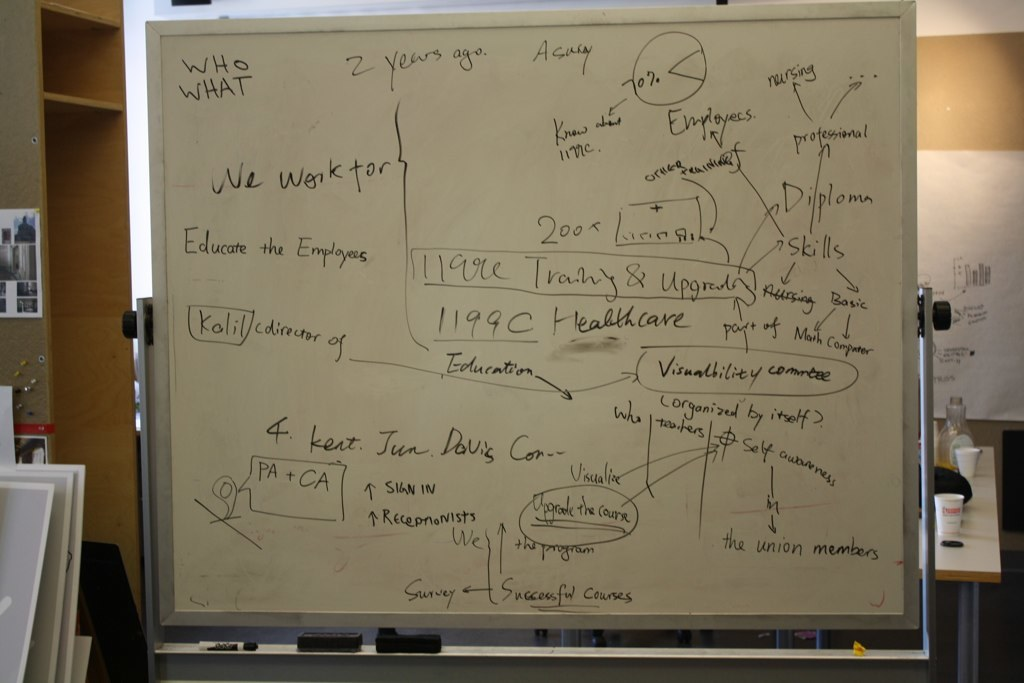Provide a one-sentence caption for the provided image. The image shows a detailed whiteboard filled with various notes about educational programs and employee training in healthcare, highlighting core aspects such as 'Educate the Employees', 'Training & Upgrading', and organizational features related to '1199C Healthcare'. 